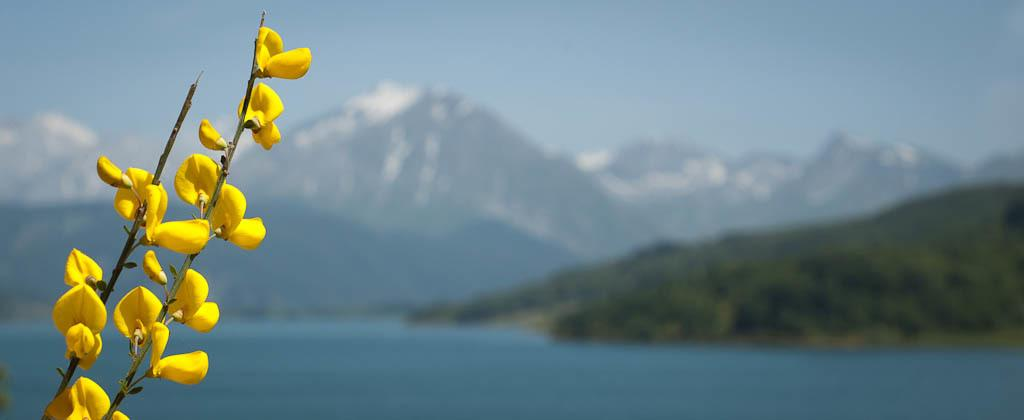What type of flowers can be seen on the left side of the image? There are yellow flowers on the left side of the image. What natural element is visible in the image? Water is visible in the image. What can be seen in the distance in the image? There are mountains in the background of the image. What is visible above the mountains in the image? The sky is visible in the image. What can be observed in the sky in the image? Clouds are present in the sky. What type of theory is being discussed in the image? There is no discussion or theory present in the image; it features yellow flowers, water, mountains, sky, and clouds. Can you tell me how many boats are docked in the harbor in the image? There is no harbor or boats present in the image; it features yellow flowers, water, mountains, sky, and clouds. 